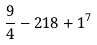Convert formula to latex. <formula><loc_0><loc_0><loc_500><loc_500>\frac { 9 } { 4 } - 2 1 8 + 1 ^ { 7 }</formula> 